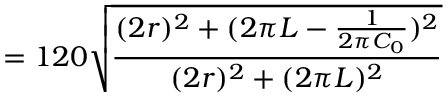<formula> <loc_0><loc_0><loc_500><loc_500>= 1 2 0 \sqrt { \frac { ( 2 r ) ^ { 2 } + ( 2 \pi L - \frac { 1 } { 2 \pi C _ { 0 } } ) ^ { 2 } } { ( 2 r ) ^ { 2 } + ( 2 \pi L ) ^ { 2 } } }</formula> 